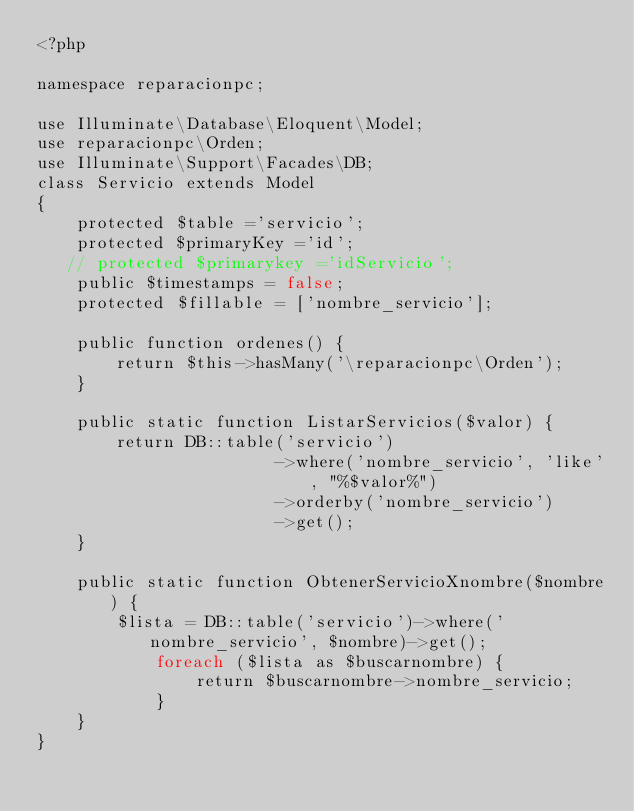<code> <loc_0><loc_0><loc_500><loc_500><_PHP_><?php

namespace reparacionpc;

use Illuminate\Database\Eloquent\Model;
use reparacionpc\Orden;
use Illuminate\Support\Facades\DB;
class Servicio extends Model
{
    protected $table ='servicio';
    protected $primaryKey ='id';
   // protected $primarykey ='idServicio';
    public $timestamps = false;
    protected $fillable = ['nombre_servicio'];
    
    public function ordenes() {
        return $this->hasMany('\reparacionpc\Orden');
    }
    
    public static function ListarServicios($valor) {
        return DB::table('servicio')
                        ->where('nombre_servicio', 'like', "%$valor%")
                        ->orderby('nombre_servicio')
                        ->get();
    }

    public static function ObtenerServicioXnombre($nombre) {
        $lista = DB::table('servicio')->where('nombre_servicio', $nombre)->get();
            foreach ($lista as $buscarnombre) {
                return $buscarnombre->nombre_servicio;
            }
    }
}
</code> 